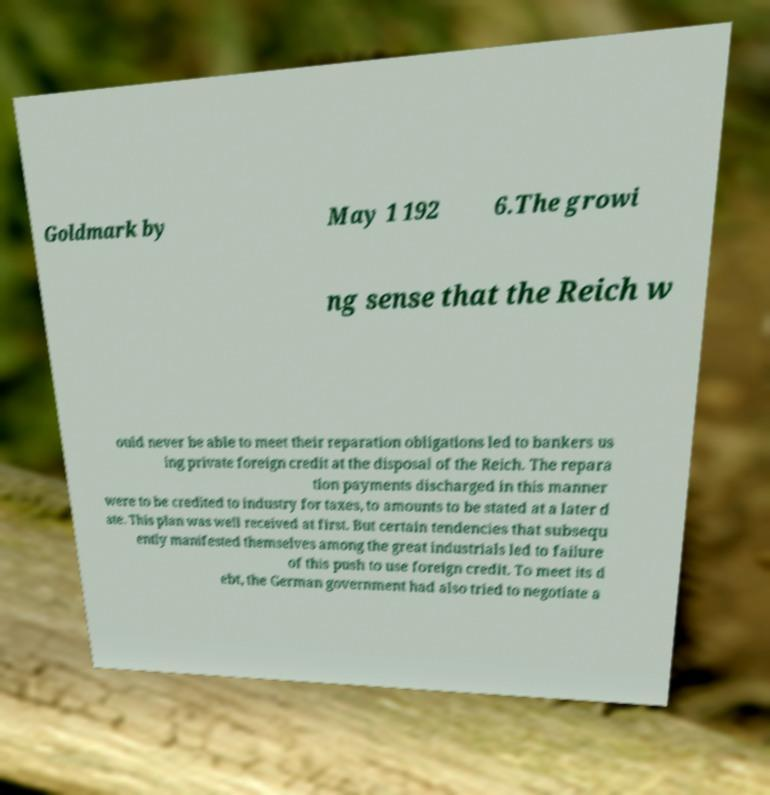I need the written content from this picture converted into text. Can you do that? Goldmark by May 1 192 6.The growi ng sense that the Reich w ould never be able to meet their reparation obligations led to bankers us ing private foreign credit at the disposal of the Reich. The repara tion payments discharged in this manner were to be credited to industry for taxes, to amounts to be stated at a later d ate. This plan was well received at first. But certain tendencies that subsequ ently manifested themselves among the great industrials led to failure of this push to use foreign credit. To meet its d ebt, the German government had also tried to negotiate a 